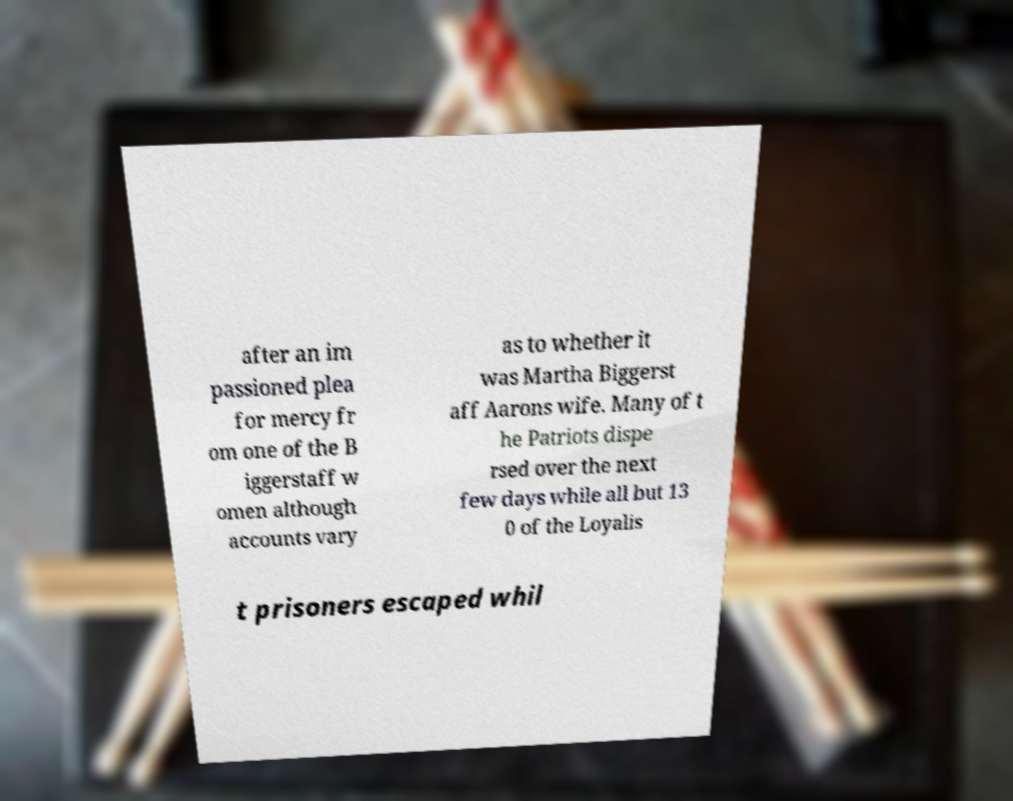What messages or text are displayed in this image? I need them in a readable, typed format. after an im passioned plea for mercy fr om one of the B iggerstaff w omen although accounts vary as to whether it was Martha Biggerst aff Aarons wife. Many of t he Patriots dispe rsed over the next few days while all but 13 0 of the Loyalis t prisoners escaped whil 